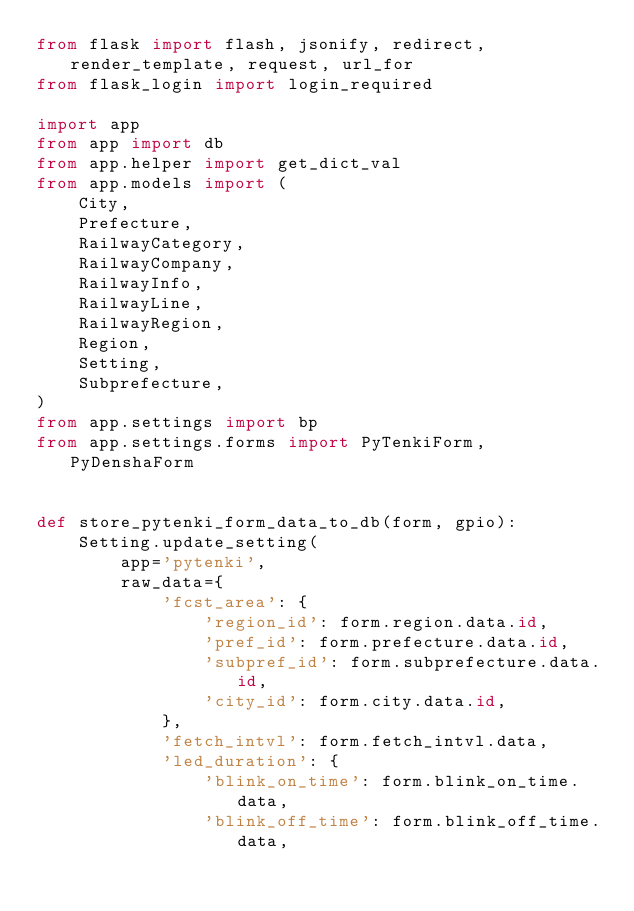<code> <loc_0><loc_0><loc_500><loc_500><_Python_>from flask import flash, jsonify, redirect, render_template, request, url_for
from flask_login import login_required

import app
from app import db
from app.helper import get_dict_val
from app.models import (
    City,
    Prefecture,
    RailwayCategory,
    RailwayCompany,
    RailwayInfo,
    RailwayLine,
    RailwayRegion,
    Region,
    Setting,
    Subprefecture,
)
from app.settings import bp
from app.settings.forms import PyTenkiForm, PyDenshaForm


def store_pytenki_form_data_to_db(form, gpio):
    Setting.update_setting(
        app='pytenki',
        raw_data={
            'fcst_area': {
                'region_id': form.region.data.id,
                'pref_id': form.prefecture.data.id,
                'subpref_id': form.subprefecture.data.id,
                'city_id': form.city.data.id,
            },
            'fetch_intvl': form.fetch_intvl.data,
            'led_duration': {
                'blink_on_time': form.blink_on_time.data,
                'blink_off_time': form.blink_off_time.data,</code> 